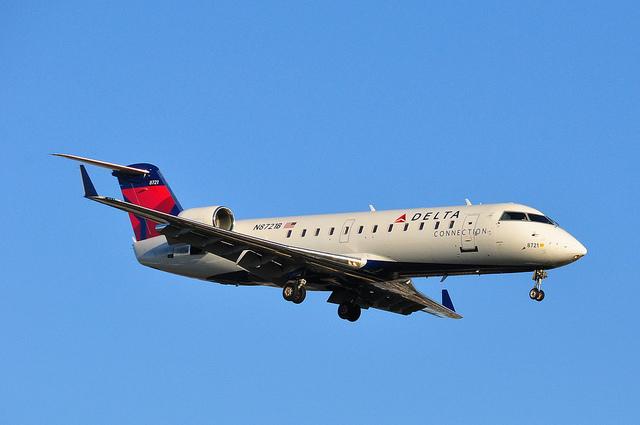What airline does this jet fly for?
Be succinct. Delta. Are there clouds in the sky?
Concise answer only. No. What kind of jet is this?
Keep it brief. Delta. 